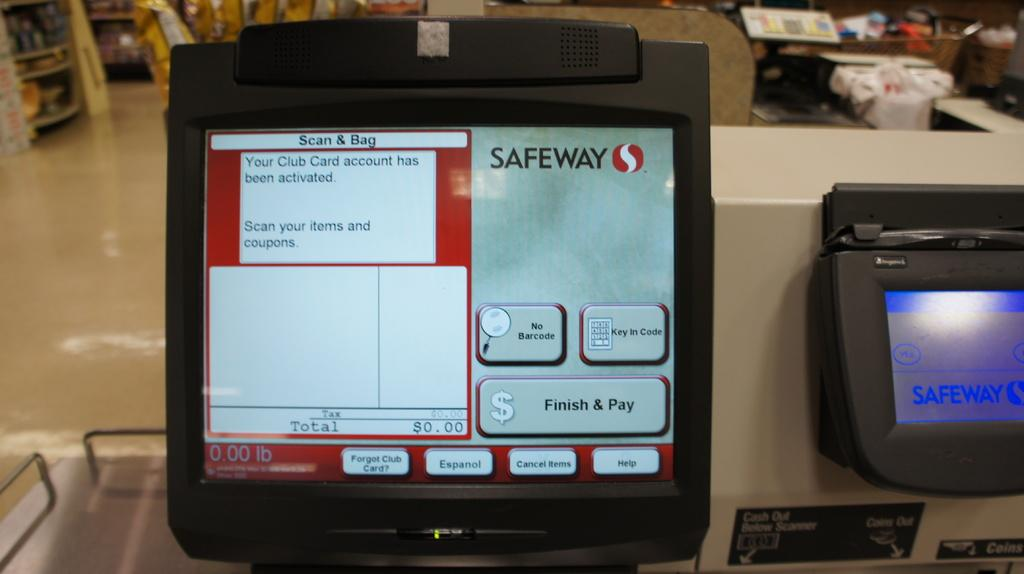Provide a one-sentence caption for the provided image. A scanning machine for Safeway states the club card is activated. 